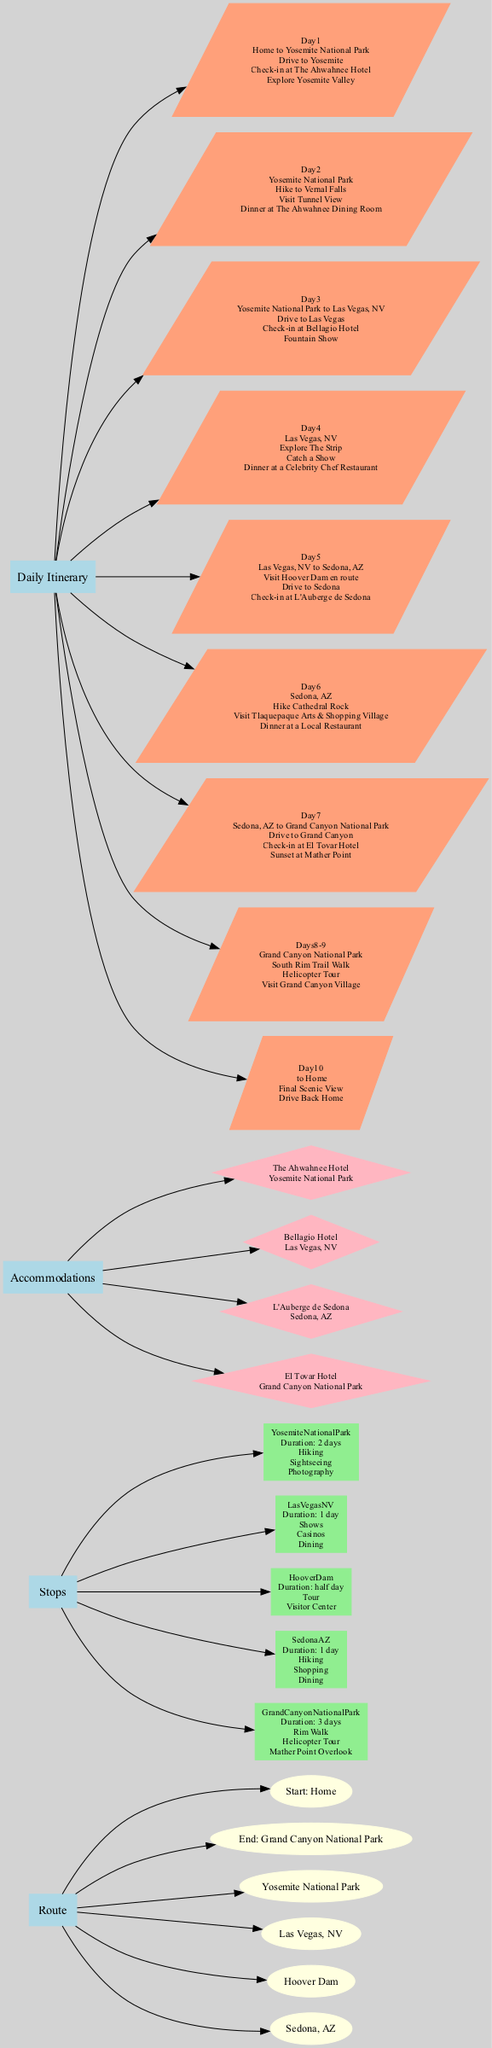What is the starting point of the road trip? The diagram indicates that the starting point of the road trip is "Home," which is directly labeled under the Route section.
Answer: Home How many major stops are included in the route? The diagram lists four major stops under the Route section, which are: Yosemite National Park, Las Vegas, NV, Hoover Dam, and Sedona, AZ.
Answer: 4 What hotel will the family stay at in Las Vegas? According to the Accommodations section of the diagram, the family stays at the "Bellagio Hotel" while they are in Las Vegas, NV.
Answer: Bellagio Hotel What activities are planned for Day 6? The diagram specifies that on Day 6, the family will have activities including "Hike Cathedral Rock," "Visit Tlaquepaque Arts & Shopping Village," and "Dinner at a Local Restaurant."
Answer: Hike Cathedral Rock, Visit Tlaquepaque Arts & Shopping Village, Dinner at a Local Restaurant What is the duration of the stay at Grand Canyon National Park? The diagram indicates a duration of "3 days" for the family's stay at Grand Canyon National Park, as specified under the Stops section.
Answer: 3 days What type of accommodations is available in addition to hotels? The diagram shows that there are alternative accommodation options listed under Accommodations, specifically types including "Camping" and "Airbnb."
Answer: Camping, Airbnb What is the last activity before heading back home? The diagram describes that the last activity before returning home is a "Final Scenic View" before the family drives back home, detailed under Day 10.
Answer: Final Scenic View Which park has a hiking activity on Day 2? The diagram specifies that "Hike to Vernal Falls" is an activity planned for Day 2, which takes place in Yosemite National Park.
Answer: Yosemite National Park How many activities are planned for Day 4? The diagram indicates three activities are scheduled for Day 4, specifically: "Explore The Strip," "Catch a Show," and "Dinner at a Celebrity Chef Restaurant."
Answer: 3 